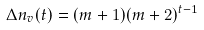<formula> <loc_0><loc_0><loc_500><loc_500>\Delta n _ { v } ( t ) = ( m + 1 ) ( m + 2 ) ^ { t - 1 }</formula> 